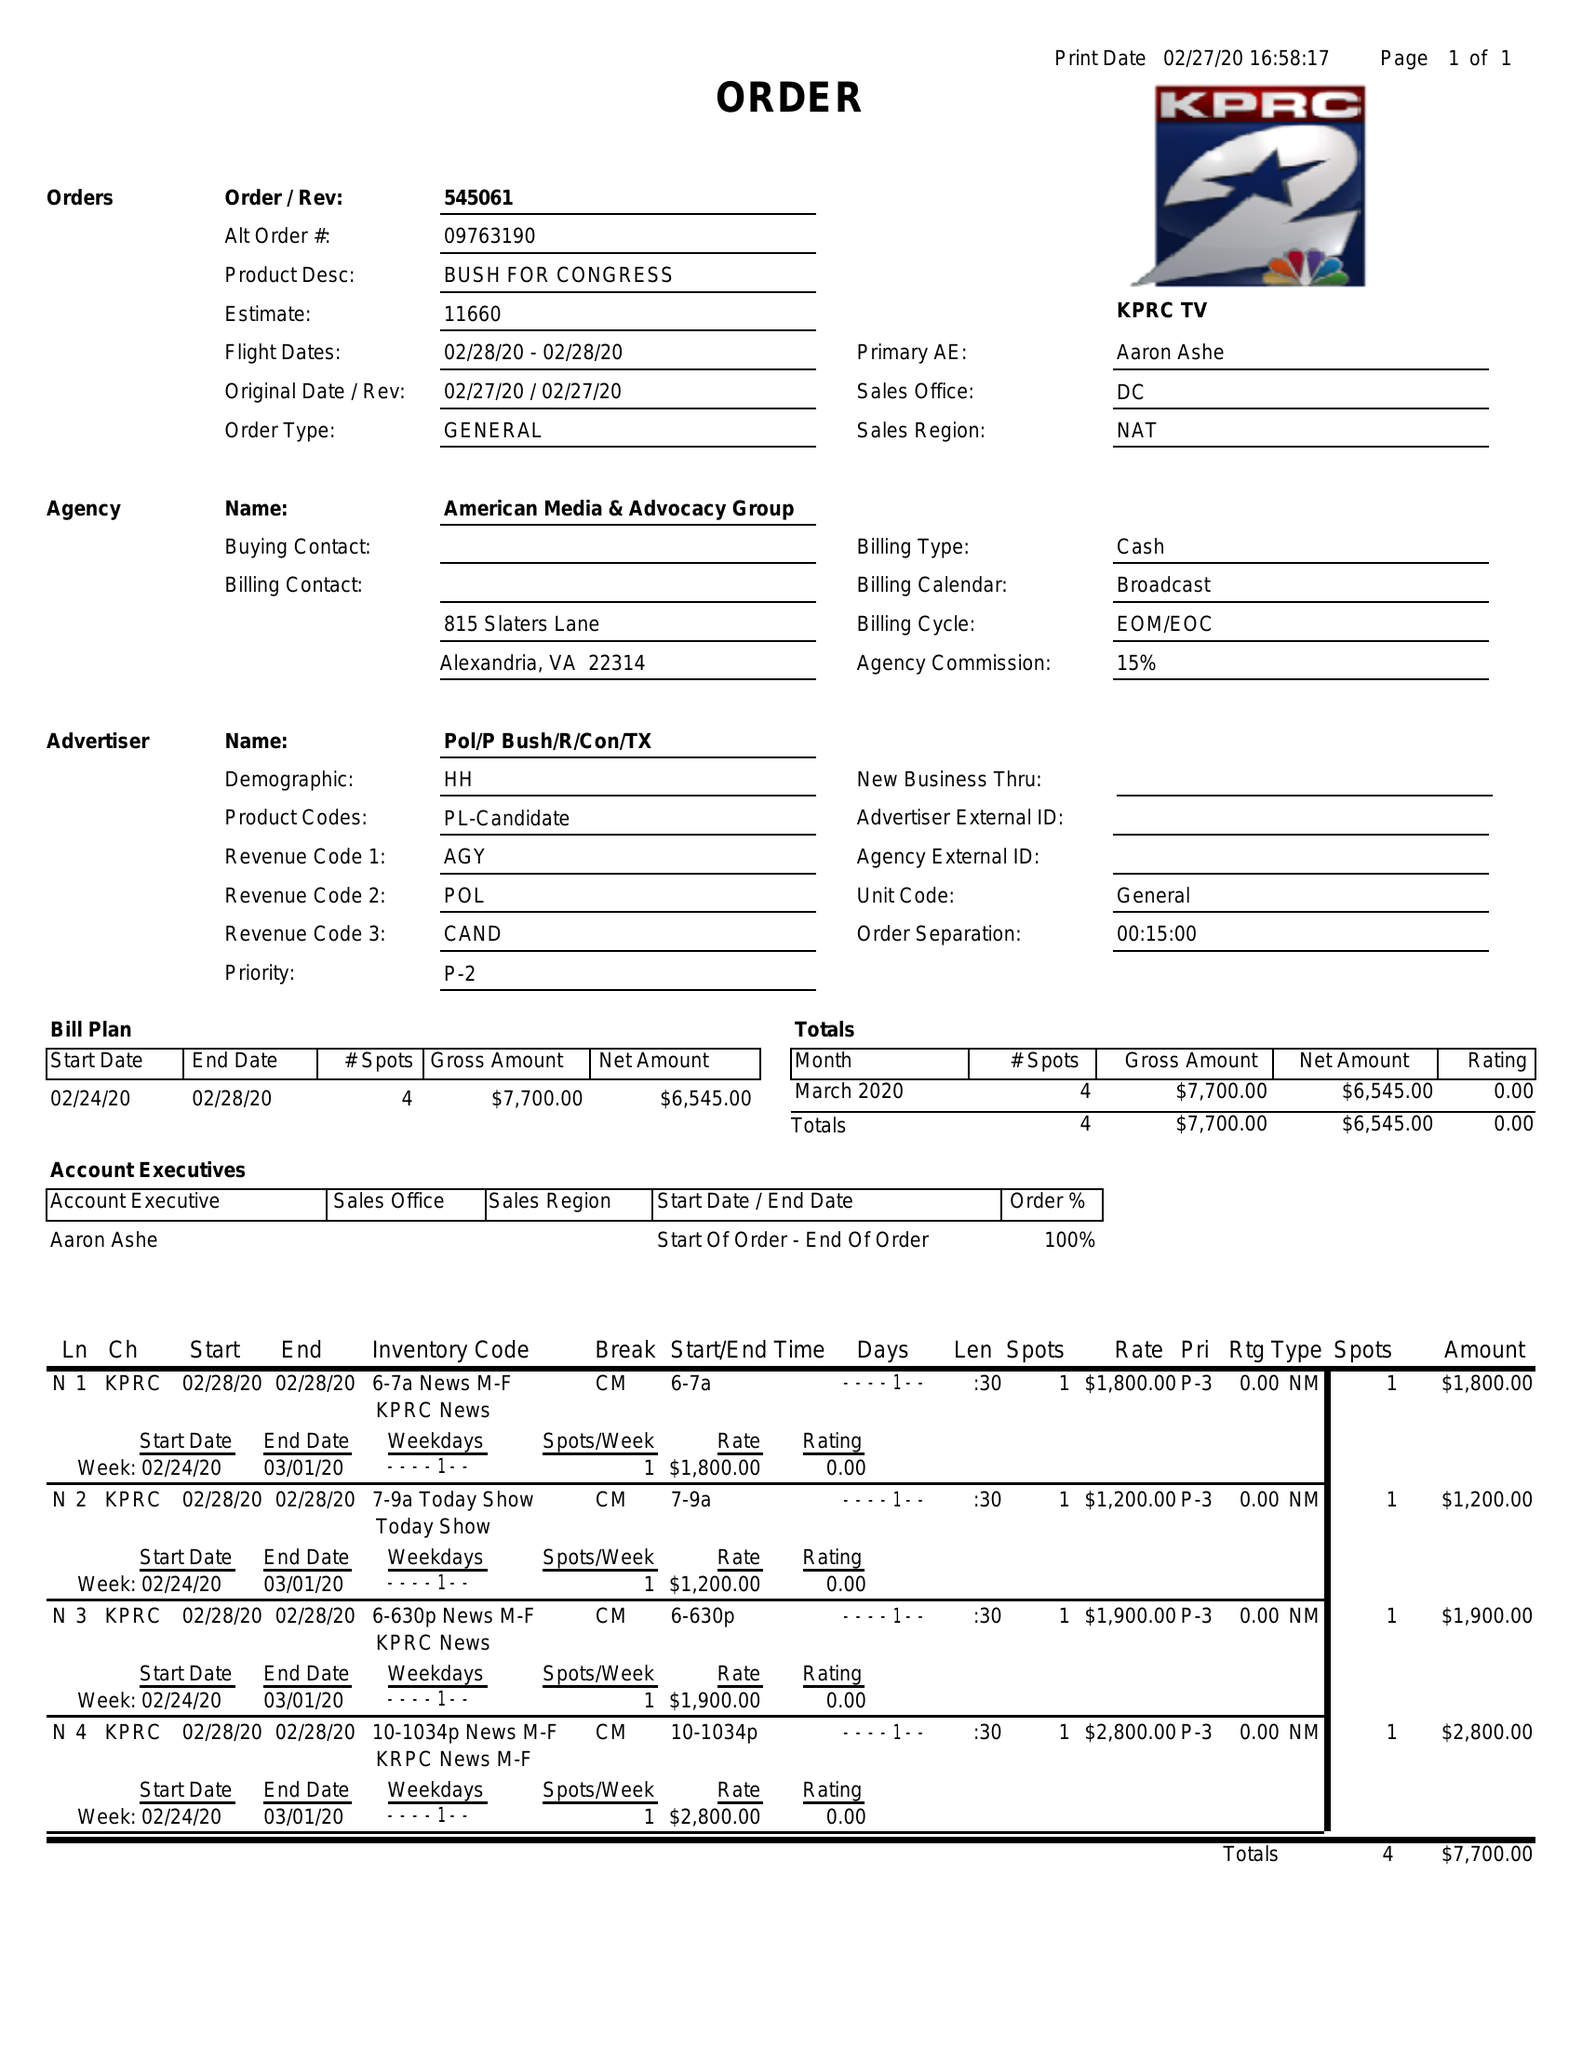What is the value for the advertiser?
Answer the question using a single word or phrase. POL/PBUSH/R/CON/TX 